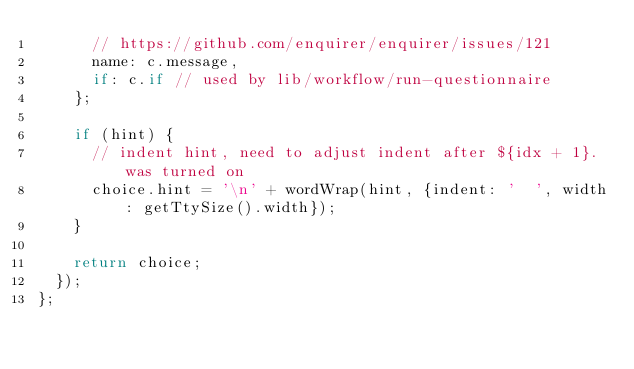<code> <loc_0><loc_0><loc_500><loc_500><_JavaScript_>      // https://github.com/enquirer/enquirer/issues/121
      name: c.message,
      if: c.if // used by lib/workflow/run-questionnaire
    };

    if (hint) {
      // indent hint, need to adjust indent after ${idx + 1}. was turned on
      choice.hint = '\n' + wordWrap(hint, {indent: '  ', width: getTtySize().width});
    }

    return choice;
  });
};
</code> 